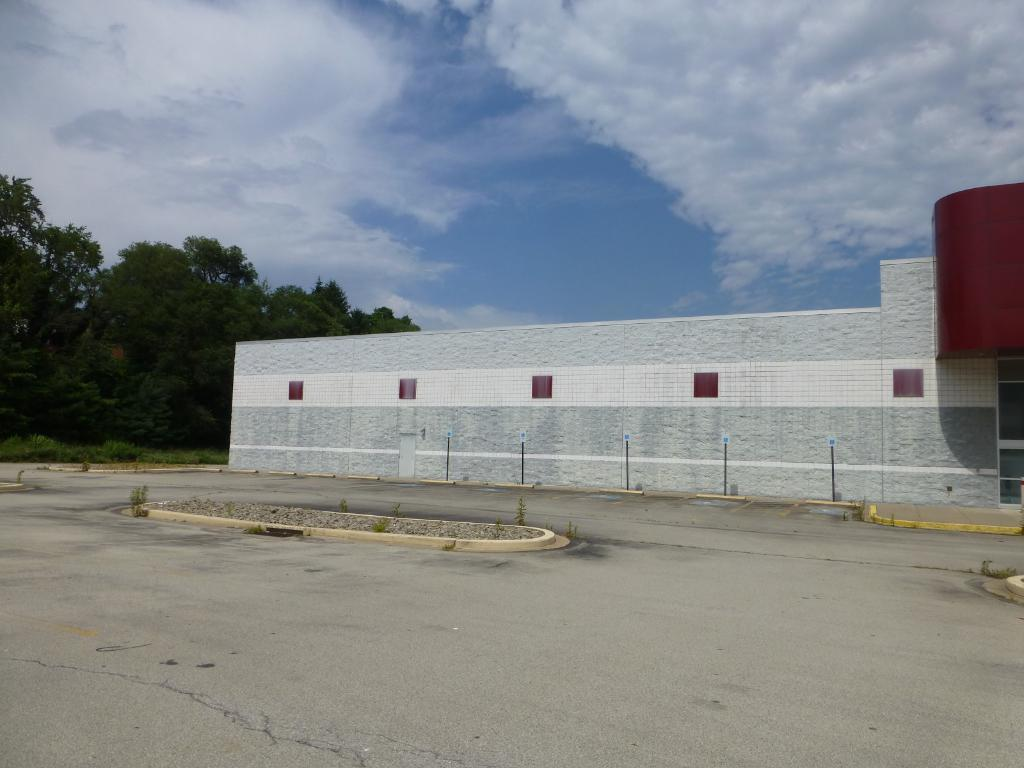What is the main feature of the image? There is a road in the image. What is located beside the road? The road is beside a wall. What type of vegetation can be seen on the left side of the image? There are trees on the left side of the image. What can be seen in the background of the image? There is a sky visible in the background of the image. How many giants are walking on the road in the image? There are no giants present in the image; it only features a road, a wall, trees, and a sky. What type of apparatus can be seen operating on the road in the image? There is no apparatus operating on the road in the image; it only features a road, a wall, trees, and a sky. 